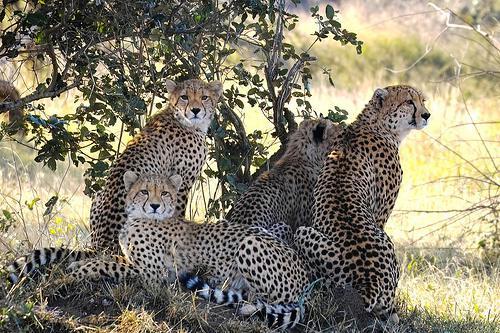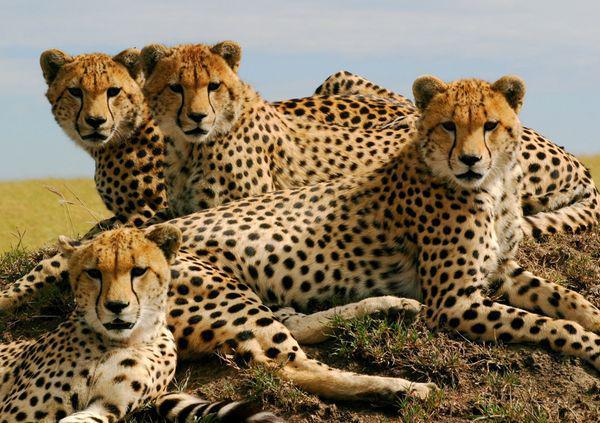The first image is the image on the left, the second image is the image on the right. Assess this claim about the two images: "there are at least three animals in the image on the left.". Correct or not? Answer yes or no. Yes. The first image is the image on the left, the second image is the image on the right. Assess this claim about the two images: "At least one image shows a group of at least three spotted cats, clustered together.". Correct or not? Answer yes or no. Yes. 